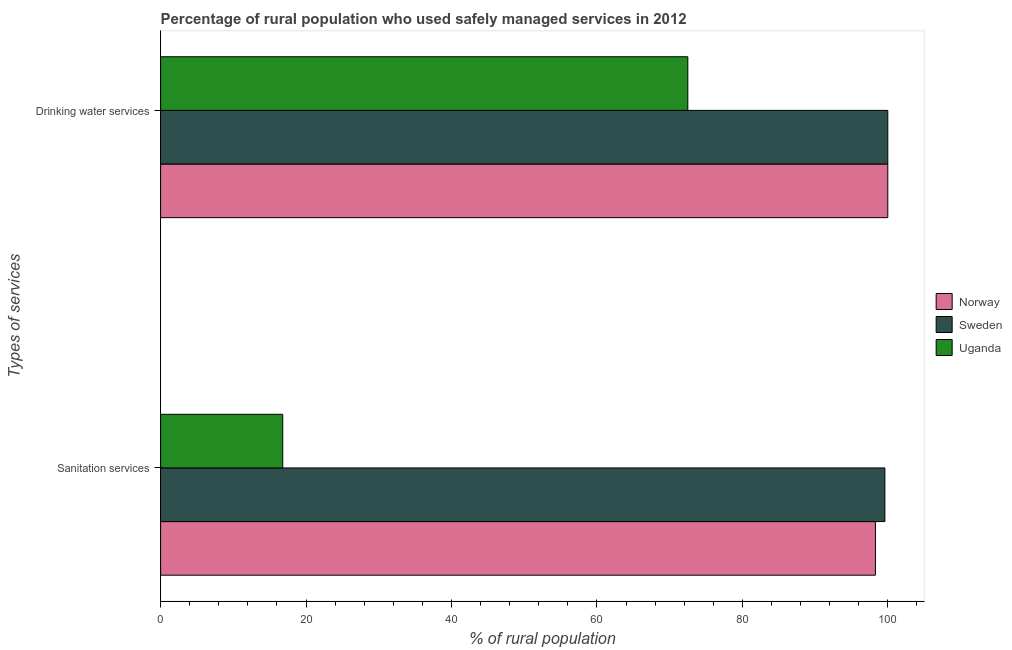Are the number of bars per tick equal to the number of legend labels?
Provide a short and direct response. Yes. Are the number of bars on each tick of the Y-axis equal?
Make the answer very short. Yes. How many bars are there on the 2nd tick from the top?
Ensure brevity in your answer.  3. How many bars are there on the 1st tick from the bottom?
Provide a short and direct response. 3. What is the label of the 2nd group of bars from the top?
Offer a very short reply. Sanitation services. What is the percentage of rural population who used drinking water services in Norway?
Ensure brevity in your answer.  100. Across all countries, what is the minimum percentage of rural population who used drinking water services?
Your answer should be very brief. 72.5. In which country was the percentage of rural population who used sanitation services minimum?
Your answer should be very brief. Uganda. What is the total percentage of rural population who used drinking water services in the graph?
Offer a very short reply. 272.5. What is the difference between the percentage of rural population who used drinking water services in Uganda and that in Sweden?
Your answer should be very brief. -27.5. What is the difference between the percentage of rural population who used sanitation services in Sweden and the percentage of rural population who used drinking water services in Uganda?
Your answer should be compact. 27.1. What is the average percentage of rural population who used sanitation services per country?
Your answer should be very brief. 71.57. What is the difference between the percentage of rural population who used drinking water services and percentage of rural population who used sanitation services in Uganda?
Your answer should be very brief. 55.7. In how many countries, is the percentage of rural population who used drinking water services greater than 72 %?
Provide a short and direct response. 3. What is the ratio of the percentage of rural population who used sanitation services in Norway to that in Sweden?
Keep it short and to the point. 0.99. Is the percentage of rural population who used sanitation services in Sweden less than that in Norway?
Your answer should be very brief. No. In how many countries, is the percentage of rural population who used drinking water services greater than the average percentage of rural population who used drinking water services taken over all countries?
Provide a short and direct response. 2. What does the 2nd bar from the top in Sanitation services represents?
Give a very brief answer. Sweden. What does the 1st bar from the bottom in Drinking water services represents?
Your answer should be very brief. Norway. How many countries are there in the graph?
Your response must be concise. 3. What is the difference between two consecutive major ticks on the X-axis?
Your response must be concise. 20. Are the values on the major ticks of X-axis written in scientific E-notation?
Provide a succinct answer. No. Does the graph contain any zero values?
Provide a short and direct response. No. Does the graph contain grids?
Ensure brevity in your answer.  No. How many legend labels are there?
Offer a very short reply. 3. What is the title of the graph?
Offer a terse response. Percentage of rural population who used safely managed services in 2012. What is the label or title of the X-axis?
Ensure brevity in your answer.  % of rural population. What is the label or title of the Y-axis?
Ensure brevity in your answer.  Types of services. What is the % of rural population in Norway in Sanitation services?
Offer a terse response. 98.3. What is the % of rural population of Sweden in Sanitation services?
Offer a very short reply. 99.6. What is the % of rural population in Uganda in Sanitation services?
Make the answer very short. 16.8. What is the % of rural population of Uganda in Drinking water services?
Keep it short and to the point. 72.5. Across all Types of services, what is the maximum % of rural population in Norway?
Your response must be concise. 100. Across all Types of services, what is the maximum % of rural population of Uganda?
Offer a terse response. 72.5. Across all Types of services, what is the minimum % of rural population in Norway?
Ensure brevity in your answer.  98.3. Across all Types of services, what is the minimum % of rural population in Sweden?
Provide a succinct answer. 99.6. What is the total % of rural population in Norway in the graph?
Offer a very short reply. 198.3. What is the total % of rural population of Sweden in the graph?
Offer a terse response. 199.6. What is the total % of rural population of Uganda in the graph?
Your response must be concise. 89.3. What is the difference between the % of rural population of Norway in Sanitation services and that in Drinking water services?
Offer a terse response. -1.7. What is the difference between the % of rural population in Uganda in Sanitation services and that in Drinking water services?
Provide a succinct answer. -55.7. What is the difference between the % of rural population in Norway in Sanitation services and the % of rural population in Uganda in Drinking water services?
Ensure brevity in your answer.  25.8. What is the difference between the % of rural population in Sweden in Sanitation services and the % of rural population in Uganda in Drinking water services?
Make the answer very short. 27.1. What is the average % of rural population in Norway per Types of services?
Your answer should be compact. 99.15. What is the average % of rural population of Sweden per Types of services?
Keep it short and to the point. 99.8. What is the average % of rural population of Uganda per Types of services?
Provide a succinct answer. 44.65. What is the difference between the % of rural population of Norway and % of rural population of Sweden in Sanitation services?
Keep it short and to the point. -1.3. What is the difference between the % of rural population in Norway and % of rural population in Uganda in Sanitation services?
Offer a terse response. 81.5. What is the difference between the % of rural population of Sweden and % of rural population of Uganda in Sanitation services?
Offer a very short reply. 82.8. What is the difference between the % of rural population in Sweden and % of rural population in Uganda in Drinking water services?
Your answer should be very brief. 27.5. What is the ratio of the % of rural population in Norway in Sanitation services to that in Drinking water services?
Your answer should be compact. 0.98. What is the ratio of the % of rural population of Sweden in Sanitation services to that in Drinking water services?
Offer a terse response. 1. What is the ratio of the % of rural population in Uganda in Sanitation services to that in Drinking water services?
Keep it short and to the point. 0.23. What is the difference between the highest and the second highest % of rural population in Uganda?
Make the answer very short. 55.7. What is the difference between the highest and the lowest % of rural population of Sweden?
Your response must be concise. 0.4. What is the difference between the highest and the lowest % of rural population of Uganda?
Make the answer very short. 55.7. 